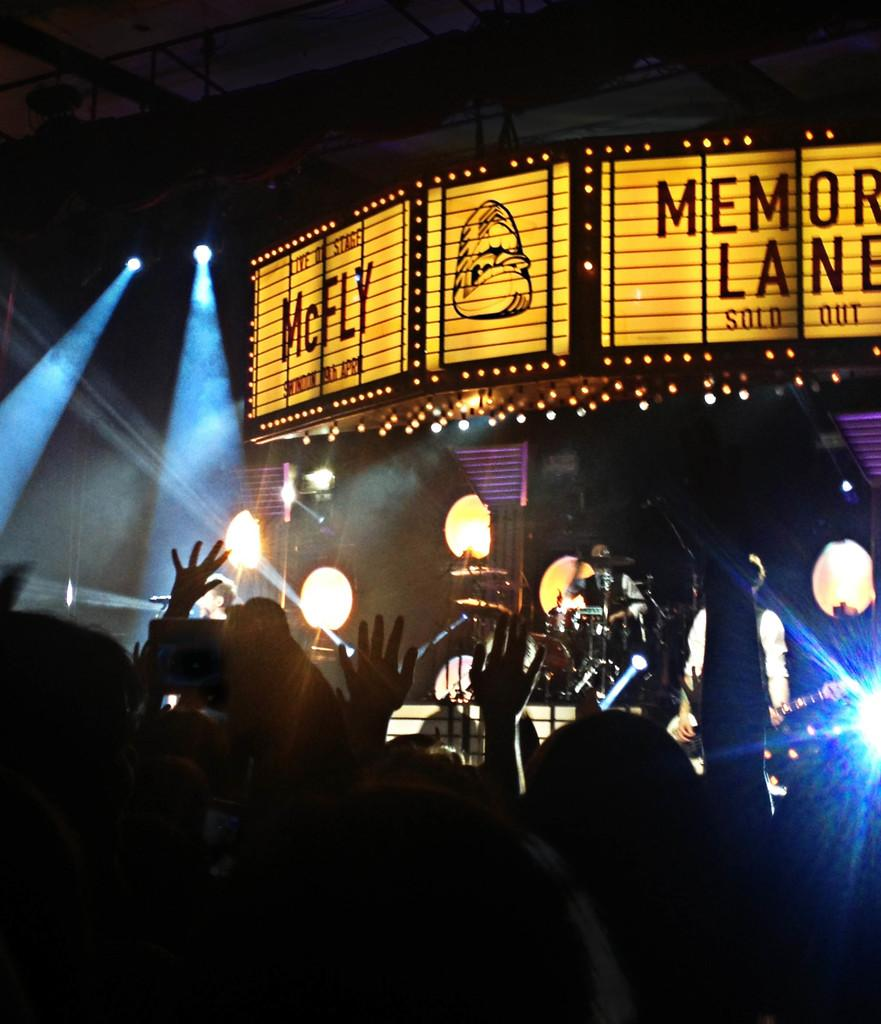What is the main subject of the image? There is a person playing a musical instrument in the image. Can you describe the background of the image? There is a board with yellow and black colors in the background. What else can be seen in the background? There are lights visible in the background. What type of ring is the girl wearing in the image? There is no girl or ring present in the image; it features a person playing a musical instrument with a background that includes a board with yellow and black colors and lights. 